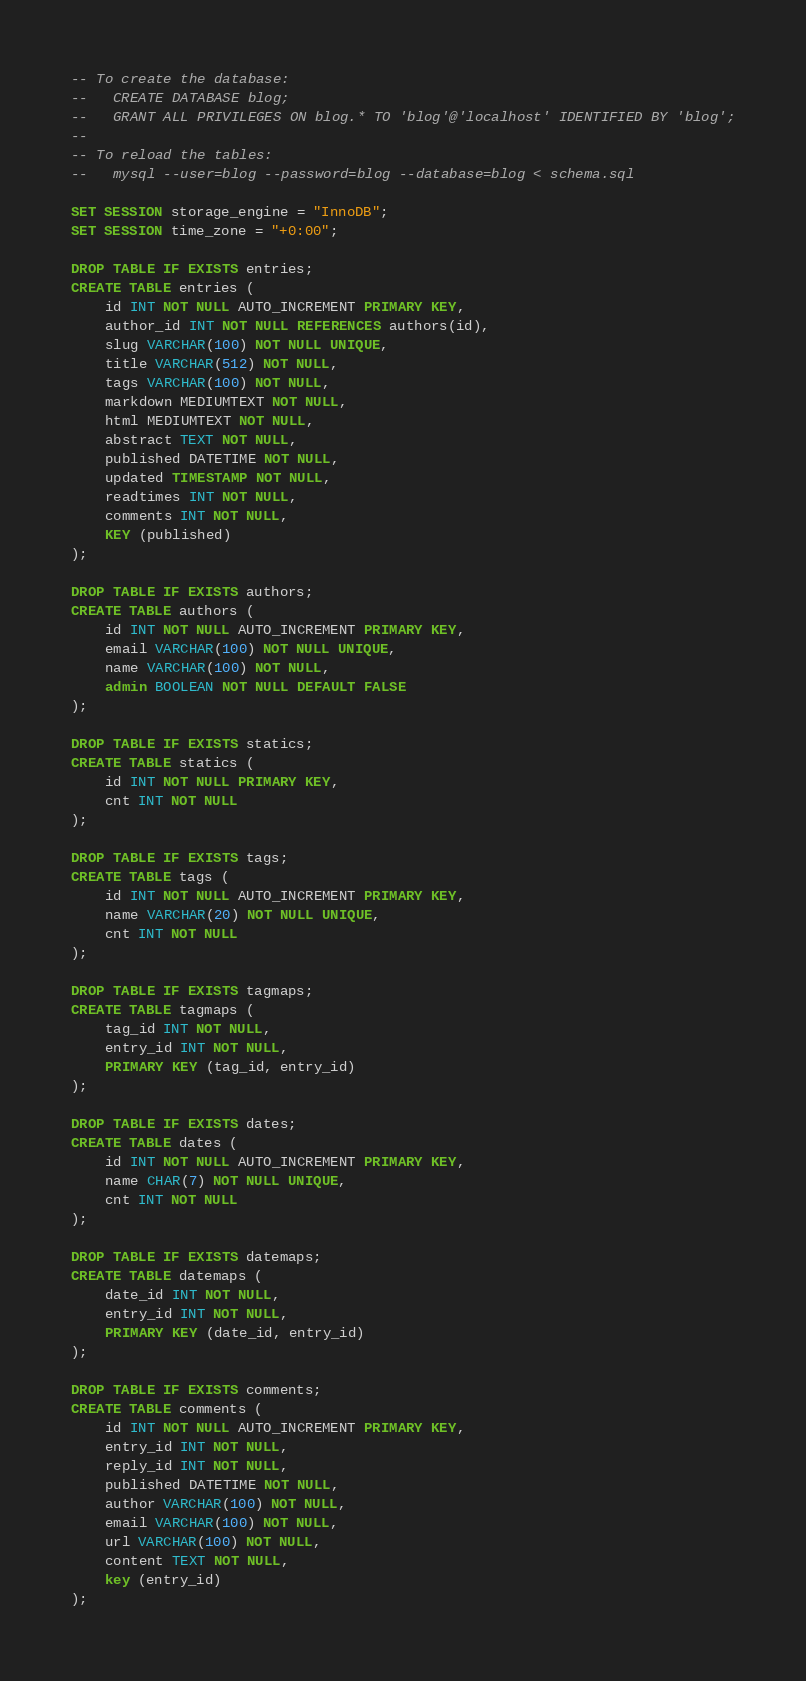<code> <loc_0><loc_0><loc_500><loc_500><_SQL_>-- To create the database:
--   CREATE DATABASE blog;
--   GRANT ALL PRIVILEGES ON blog.* TO 'blog'@'localhost' IDENTIFIED BY 'blog';
--
-- To reload the tables:
--   mysql --user=blog --password=blog --database=blog < schema.sql

SET SESSION storage_engine = "InnoDB";
SET SESSION time_zone = "+0:00";

DROP TABLE IF EXISTS entries;
CREATE TABLE entries (
    id INT NOT NULL AUTO_INCREMENT PRIMARY KEY,
    author_id INT NOT NULL REFERENCES authors(id),
    slug VARCHAR(100) NOT NULL UNIQUE,
    title VARCHAR(512) NOT NULL,
    tags VARCHAR(100) NOT NULL,
    markdown MEDIUMTEXT NOT NULL,
    html MEDIUMTEXT NOT NULL,
    abstract TEXT NOT NULL,
    published DATETIME NOT NULL,
    updated TIMESTAMP NOT NULL,
	readtimes INT NOT NULL,
	comments INT NOT NULL,
    KEY (published)
);

DROP TABLE IF EXISTS authors;
CREATE TABLE authors (
    id INT NOT NULL AUTO_INCREMENT PRIMARY KEY,
    email VARCHAR(100) NOT NULL UNIQUE,
    name VARCHAR(100) NOT NULL,
    admin BOOLEAN NOT NULL DEFAULT FALSE
);

DROP TABLE IF EXISTS statics;
CREATE TABLE statics (
	id INT NOT NULL PRIMARY KEY,
	cnt INT NOT NULL 
);

DROP TABLE IF EXISTS tags;
CREATE TABLE tags (
	id INT NOT NULL AUTO_INCREMENT PRIMARY KEY,
	name VARCHAR(20) NOT NULL UNIQUE,
	cnt INT NOT NULL
);

DROP TABLE IF EXISTS tagmaps;
CREATE TABLE tagmaps (
	tag_id INT NOT NULL,
	entry_id INT NOT NULL,
	PRIMARY KEY (tag_id, entry_id)
);

DROP TABLE IF EXISTS dates;
CREATE TABLE dates (
	id INT NOT NULL AUTO_INCREMENT PRIMARY KEY,
	name CHAR(7) NOT NULL UNIQUE,
	cnt INT NOT NULL
);

DROP TABLE IF EXISTS datemaps;
CREATE TABLE datemaps (
	date_id INT NOT NULL,
	entry_id INT NOT NULL,
	PRIMARY KEY (date_id, entry_id)
);

DROP TABLE IF EXISTS comments;
CREATE TABLE comments (
	id INT NOT NULL AUTO_INCREMENT PRIMARY KEY,
	entry_id INT NOT NULL,
    reply_id INT NOT NULL,
	published DATETIME NOT NULL,
	author VARCHAR(100) NOT NULL,
	email VARCHAR(100) NOT NULL,
	url VARCHAR(100) NOT NULL,
	content TEXT NOT NULL,
	key (entry_id)
);
</code> 